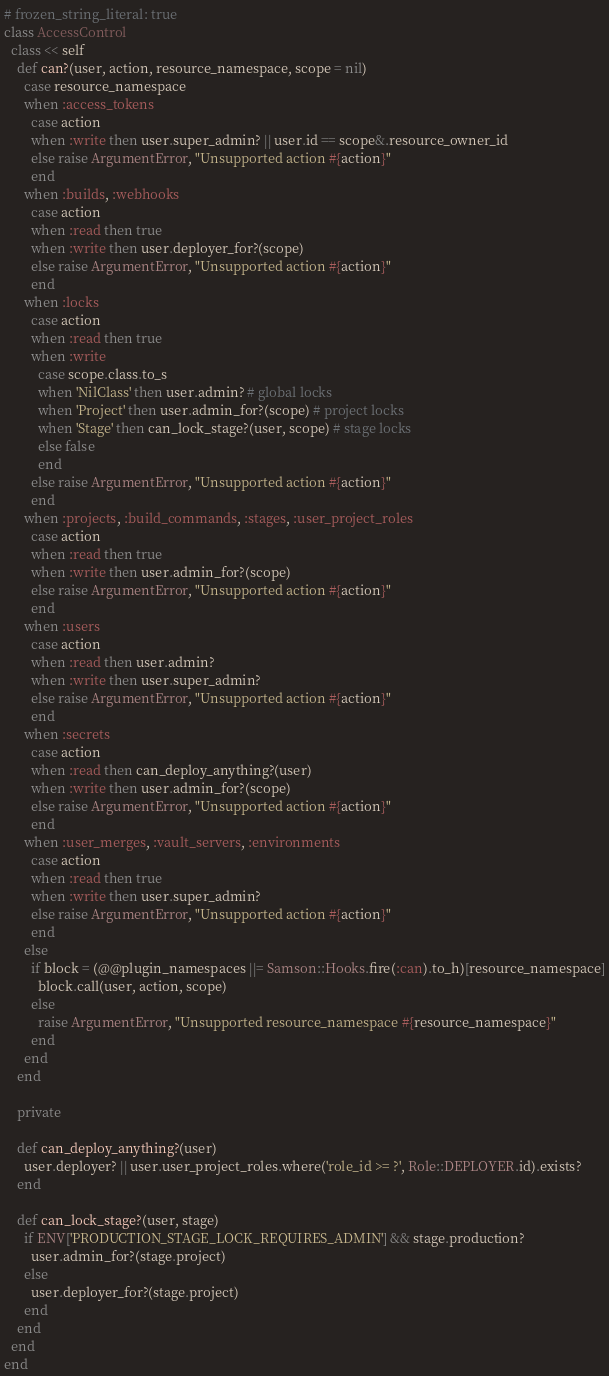Convert code to text. <code><loc_0><loc_0><loc_500><loc_500><_Ruby_># frozen_string_literal: true
class AccessControl
  class << self
    def can?(user, action, resource_namespace, scope = nil)
      case resource_namespace
      when :access_tokens
        case action
        when :write then user.super_admin? || user.id == scope&.resource_owner_id
        else raise ArgumentError, "Unsupported action #{action}"
        end
      when :builds, :webhooks
        case action
        when :read then true
        when :write then user.deployer_for?(scope)
        else raise ArgumentError, "Unsupported action #{action}"
        end
      when :locks
        case action
        when :read then true
        when :write
          case scope.class.to_s
          when 'NilClass' then user.admin? # global locks
          when 'Project' then user.admin_for?(scope) # project locks
          when 'Stage' then can_lock_stage?(user, scope) # stage locks
          else false
          end
        else raise ArgumentError, "Unsupported action #{action}"
        end
      when :projects, :build_commands, :stages, :user_project_roles
        case action
        when :read then true
        when :write then user.admin_for?(scope)
        else raise ArgumentError, "Unsupported action #{action}"
        end
      when :users
        case action
        when :read then user.admin?
        when :write then user.super_admin?
        else raise ArgumentError, "Unsupported action #{action}"
        end
      when :secrets
        case action
        when :read then can_deploy_anything?(user)
        when :write then user.admin_for?(scope)
        else raise ArgumentError, "Unsupported action #{action}"
        end
      when :user_merges, :vault_servers, :environments
        case action
        when :read then true
        when :write then user.super_admin?
        else raise ArgumentError, "Unsupported action #{action}"
        end
      else
        if block = (@@plugin_namespaces ||= Samson::Hooks.fire(:can).to_h)[resource_namespace]
          block.call(user, action, scope)
        else
          raise ArgumentError, "Unsupported resource_namespace #{resource_namespace}"
        end
      end
    end

    private

    def can_deploy_anything?(user)
      user.deployer? || user.user_project_roles.where('role_id >= ?', Role::DEPLOYER.id).exists?
    end

    def can_lock_stage?(user, stage)
      if ENV['PRODUCTION_STAGE_LOCK_REQUIRES_ADMIN'] && stage.production?
        user.admin_for?(stage.project)
      else
        user.deployer_for?(stage.project)
      end
    end
  end
end
</code> 